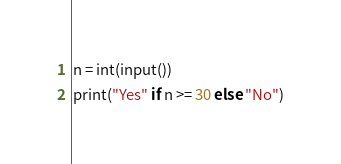Convert code to text. <code><loc_0><loc_0><loc_500><loc_500><_Python_>n = int(input())
print("Yes" if n >= 30 else "No")</code> 